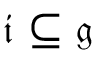Convert formula to latex. <formula><loc_0><loc_0><loc_500><loc_500>{ \mathfrak { i } } \subseteq { \mathfrak { g } }</formula> 